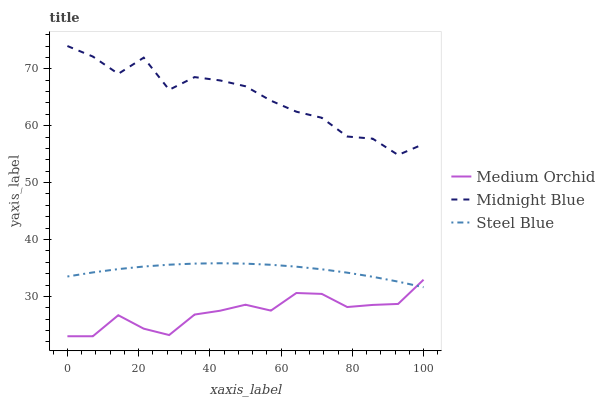Does Medium Orchid have the minimum area under the curve?
Answer yes or no. Yes. Does Midnight Blue have the maximum area under the curve?
Answer yes or no. Yes. Does Steel Blue have the minimum area under the curve?
Answer yes or no. No. Does Steel Blue have the maximum area under the curve?
Answer yes or no. No. Is Steel Blue the smoothest?
Answer yes or no. Yes. Is Midnight Blue the roughest?
Answer yes or no. Yes. Is Midnight Blue the smoothest?
Answer yes or no. No. Is Steel Blue the roughest?
Answer yes or no. No. Does Steel Blue have the lowest value?
Answer yes or no. No. Does Midnight Blue have the highest value?
Answer yes or no. Yes. Does Steel Blue have the highest value?
Answer yes or no. No. Is Medium Orchid less than Midnight Blue?
Answer yes or no. Yes. Is Midnight Blue greater than Steel Blue?
Answer yes or no. Yes. Does Medium Orchid intersect Steel Blue?
Answer yes or no. Yes. Is Medium Orchid less than Steel Blue?
Answer yes or no. No. Is Medium Orchid greater than Steel Blue?
Answer yes or no. No. Does Medium Orchid intersect Midnight Blue?
Answer yes or no. No. 